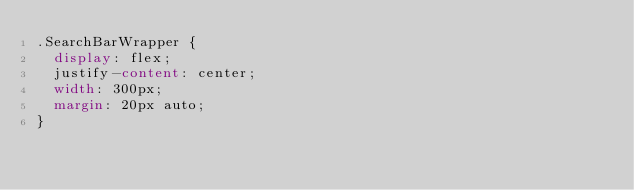Convert code to text. <code><loc_0><loc_0><loc_500><loc_500><_CSS_>.SearchBarWrapper {
  display: flex;
  justify-content: center;
  width: 300px;
  margin: 20px auto;
}</code> 